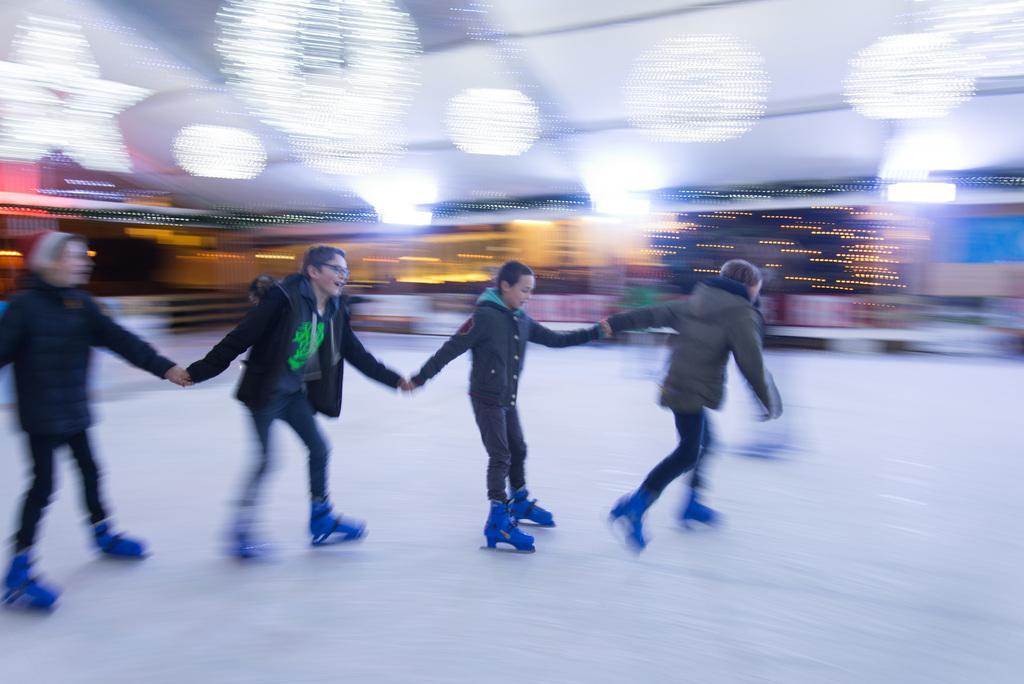Can you describe this image briefly? In this image, there are a few people skating. We can see the ground and the blurred background. 